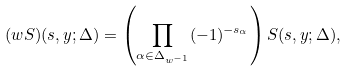Convert formula to latex. <formula><loc_0><loc_0><loc_500><loc_500>( w S ) ( s , y ; \Delta ) = \left ( \prod _ { \alpha \in \Delta _ { w ^ { - 1 } } } ( - 1 ) ^ { - s _ { \alpha } } \right ) S ( s , y ; \Delta ) ,</formula> 